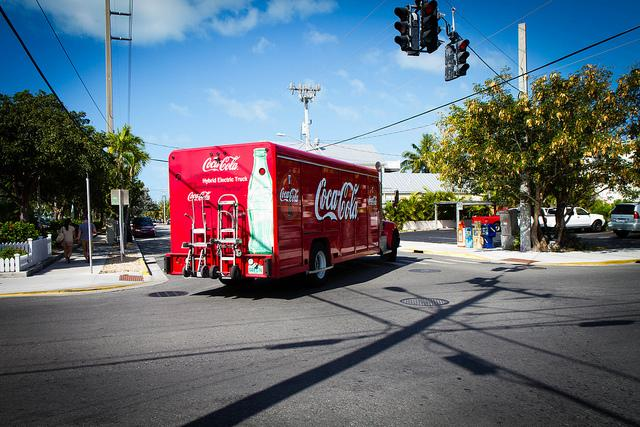Why is the truck in the middle of the street?

Choices:
A) parking
B) turning left
C) no gas
D) broken down turning left 